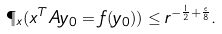<formula> <loc_0><loc_0><loc_500><loc_500>\P _ { x } ( x ^ { T } A y _ { 0 } = f ( y _ { 0 } ) ) \leq r ^ { - \frac { 1 } { 2 } + \frac { \epsilon } { 8 } } .</formula> 